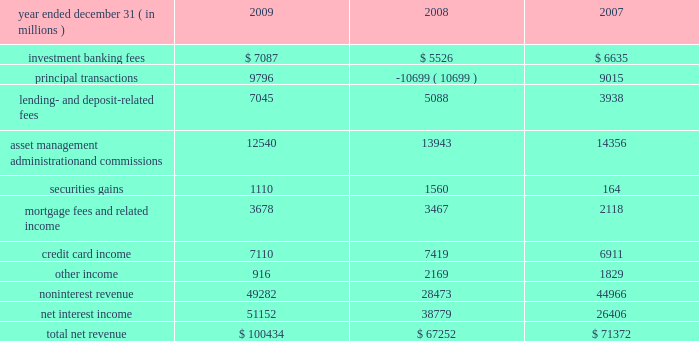Jpmorgan chase & co./2009 annual report consolidated results of operations this following section provides a comparative discussion of jpmorgan chase 2019s consolidated results of operations on a reported basis for the three-year period ended december 31 , 2009 .
Factors that related primarily to a single business segment are discussed in more detail within that business segment .
For a discussion of the critical ac- counting estimates used by the firm that affect the consolidated results of operations , see pages 135 2013139 of this annual report .
Revenue year ended december 31 , ( in millions ) 2009 2008 2007 .
2009 compared with 2008 total net revenue was $ 100.4 billion , up by $ 33.2 billion , or 49% ( 49 % ) , from the prior year .
The increase was driven by higher principal transactions revenue , primarily related to improved performance across most fixed income and equity products , and the absence of net markdowns on legacy leveraged lending and mortgage positions in ib , as well as higher levels of trading gains and investment securities income in corporate/private equity .
Results also benefited from the impact of the washington mutual transaction , which contributed to increases in net interest income , lending- and deposit-related fees , and mortgage fees and related income .
Lastly , higher investment banking fees also contributed to revenue growth .
These increases in revenue were offset partially by reduced fees and commissions from the effect of lower market levels on assets under management and custody , and the absence of proceeds from the sale of visa shares in its initial public offering in the first quarter of 2008 .
Investment banking fees increased from the prior year , due to higher equity and debt underwriting fees .
For a further discussion of invest- ment banking fees , which are primarily recorded in ib , see ib segment results on pages 63 201365 of this annual report .
Principal transactions revenue , which consists of revenue from trading and private equity investing activities , was significantly higher com- pared with the prior year .
Trading revenue increased , driven by improved performance across most fixed income and equity products ; modest net gains on legacy leveraged lending and mortgage-related positions , compared with net markdowns of $ 10.6 billion in the prior year ; and gains on trading positions in corporate/private equity , compared with losses in the prior year of $ 1.1 billion on markdowns of federal national mortgage association ( 201cfannie mae 201d ) and fed- eral home loan mortgage corporation ( 201cfreddie mac 201d ) preferred securities .
These increases in revenue were offset partially by an aggregate loss of $ 2.3 billion from the tightening of the firm 2019s credit spread on certain structured liabilities and derivatives , compared with gains of $ 2.0 billion in the prior year from widening spreads on these liabilities and derivatives .
The firm 2019s private equity investments pro- duced a slight net loss in 2009 , a significant improvement from a larger net loss in 2008 .
For a further discussion of principal transac- tions revenue , see ib and corporate/private equity segment results on pages 63 201365 and 82 201383 , respectively , and note 3 on pages 156 2013 173 of this annual report .
Lending- and deposit-related fees rose from the prior year , predomi- nantly reflecting the impact of the washington mutual transaction and organic growth in both lending- and deposit-related fees in rfs , cb , ib and tss .
For a further discussion of lending- and deposit- related fees , which are mostly recorded in rfs , tss and cb , see the rfs segment results on pages 66 201371 , the tss segment results on pages 77 201378 , and the cb segment results on pages 75 201376 of this annual report .
The decline in asset management , administration and commissions revenue compared with the prior year was largely due to lower asset management fees in am from the effect of lower market levels .
Also contributing to the decrease were lower administration fees in tss , driven by the effect of market depreciation on certain custody assets and lower securities lending balances ; and lower brokerage commis- sions revenue in ib , predominantly related to lower transaction vol- ume .
For additional information on these fees and commissions , see the segment discussions for tss on pages 77 201378 , and am on pages 79 201381 of this annual report .
Securities gains were lower in 2009 and included credit losses related to other-than-temporary impairment and lower gains on the sale of mastercard shares of $ 241 million in 2009 , compared with $ 668 million in 2008 .
These decreases were offset partially by higher gains from repositioning the corporate investment securities portfolio in connection with managing the firm 2019s structural interest rate risk .
For a further discussion of securities gains , which are mostly recorded in corporate/private equity , see the corpo- rate/private equity segment discussion on pages 82 201383 of this annual report .
Mortgage fees and related income increased slightly from the prior year , as higher net mortgage servicing revenue was largely offset by lower production revenue .
The increase in net mortgage servicing revenue was driven by growth in average third-party loans serviced as a result of the washington mutual transaction .
Mortgage production revenue declined from the prior year , reflecting an increase in esti- mated losses from the repurchase of previously-sold loans , offset partially by wider margins on new originations .
For a discussion of mortgage fees and related income , which is recorded primarily in rfs 2019s consumer lending business , see the consumer lending discus- sion on pages 68 201371 of this annual report .
Credit card income , which includes the impact of the washington mutual transaction , decreased slightly compared with the prior year .
What percent of total net revenue was noninterest revenue in 2009? 
Computations: (49282 / 100434)
Answer: 0.49069. 